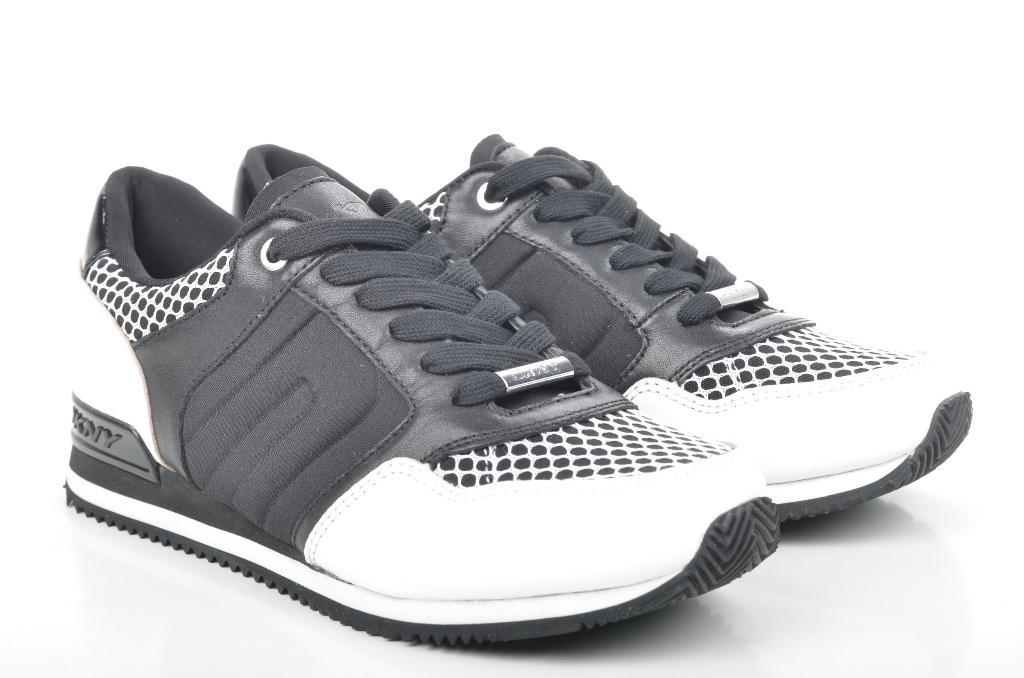What color is the background of the image? The background of the image is white. What type of shoes can be seen in the image? There are black and white shoes in the image. What word is written on the shoes in the image? There is no word written on the shoes in the image; they are simply black and white. 